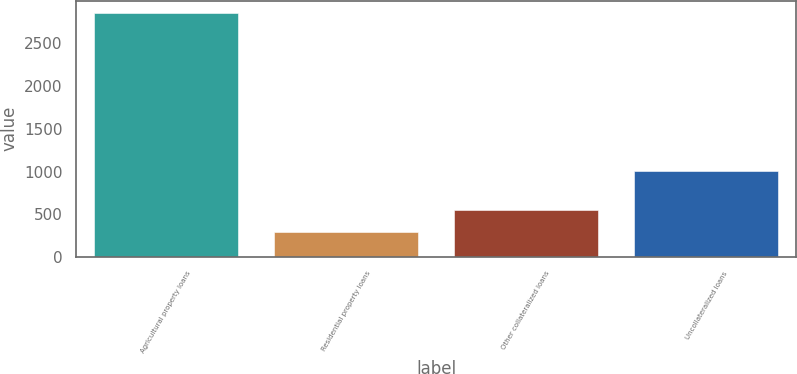Convert chart to OTSL. <chart><loc_0><loc_0><loc_500><loc_500><bar_chart><fcel>Agricultural property loans<fcel>Residential property loans<fcel>Other collateralized loans<fcel>Uncollateralized loans<nl><fcel>2856<fcel>288<fcel>544.8<fcel>1012<nl></chart> 